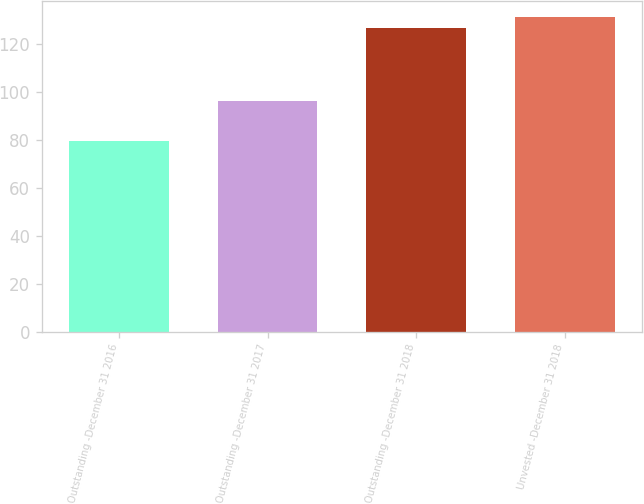<chart> <loc_0><loc_0><loc_500><loc_500><bar_chart><fcel>Outstanding -December 31 2016<fcel>Outstanding -December 31 2017<fcel>Outstanding -December 31 2018<fcel>Unvested -December 31 2018<nl><fcel>79.72<fcel>96.23<fcel>126.93<fcel>131.65<nl></chart> 